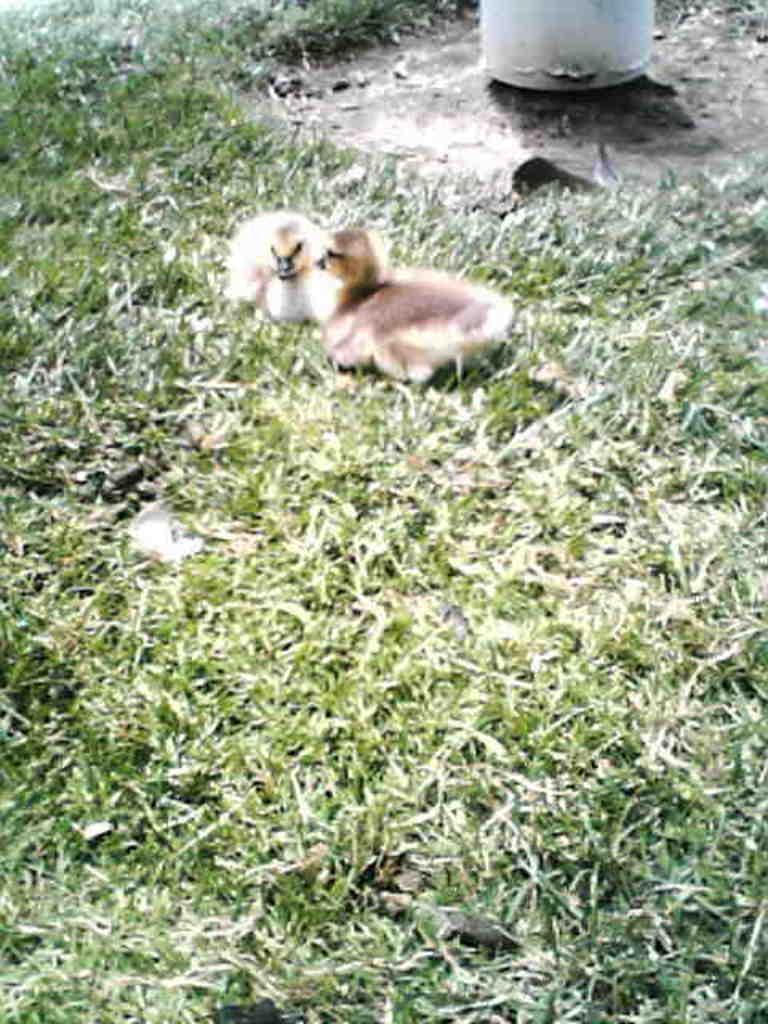Can you describe this image briefly? In the center of the picture there are two ducklings. In the foreground and at the top there is grass. At the top there is an object. 